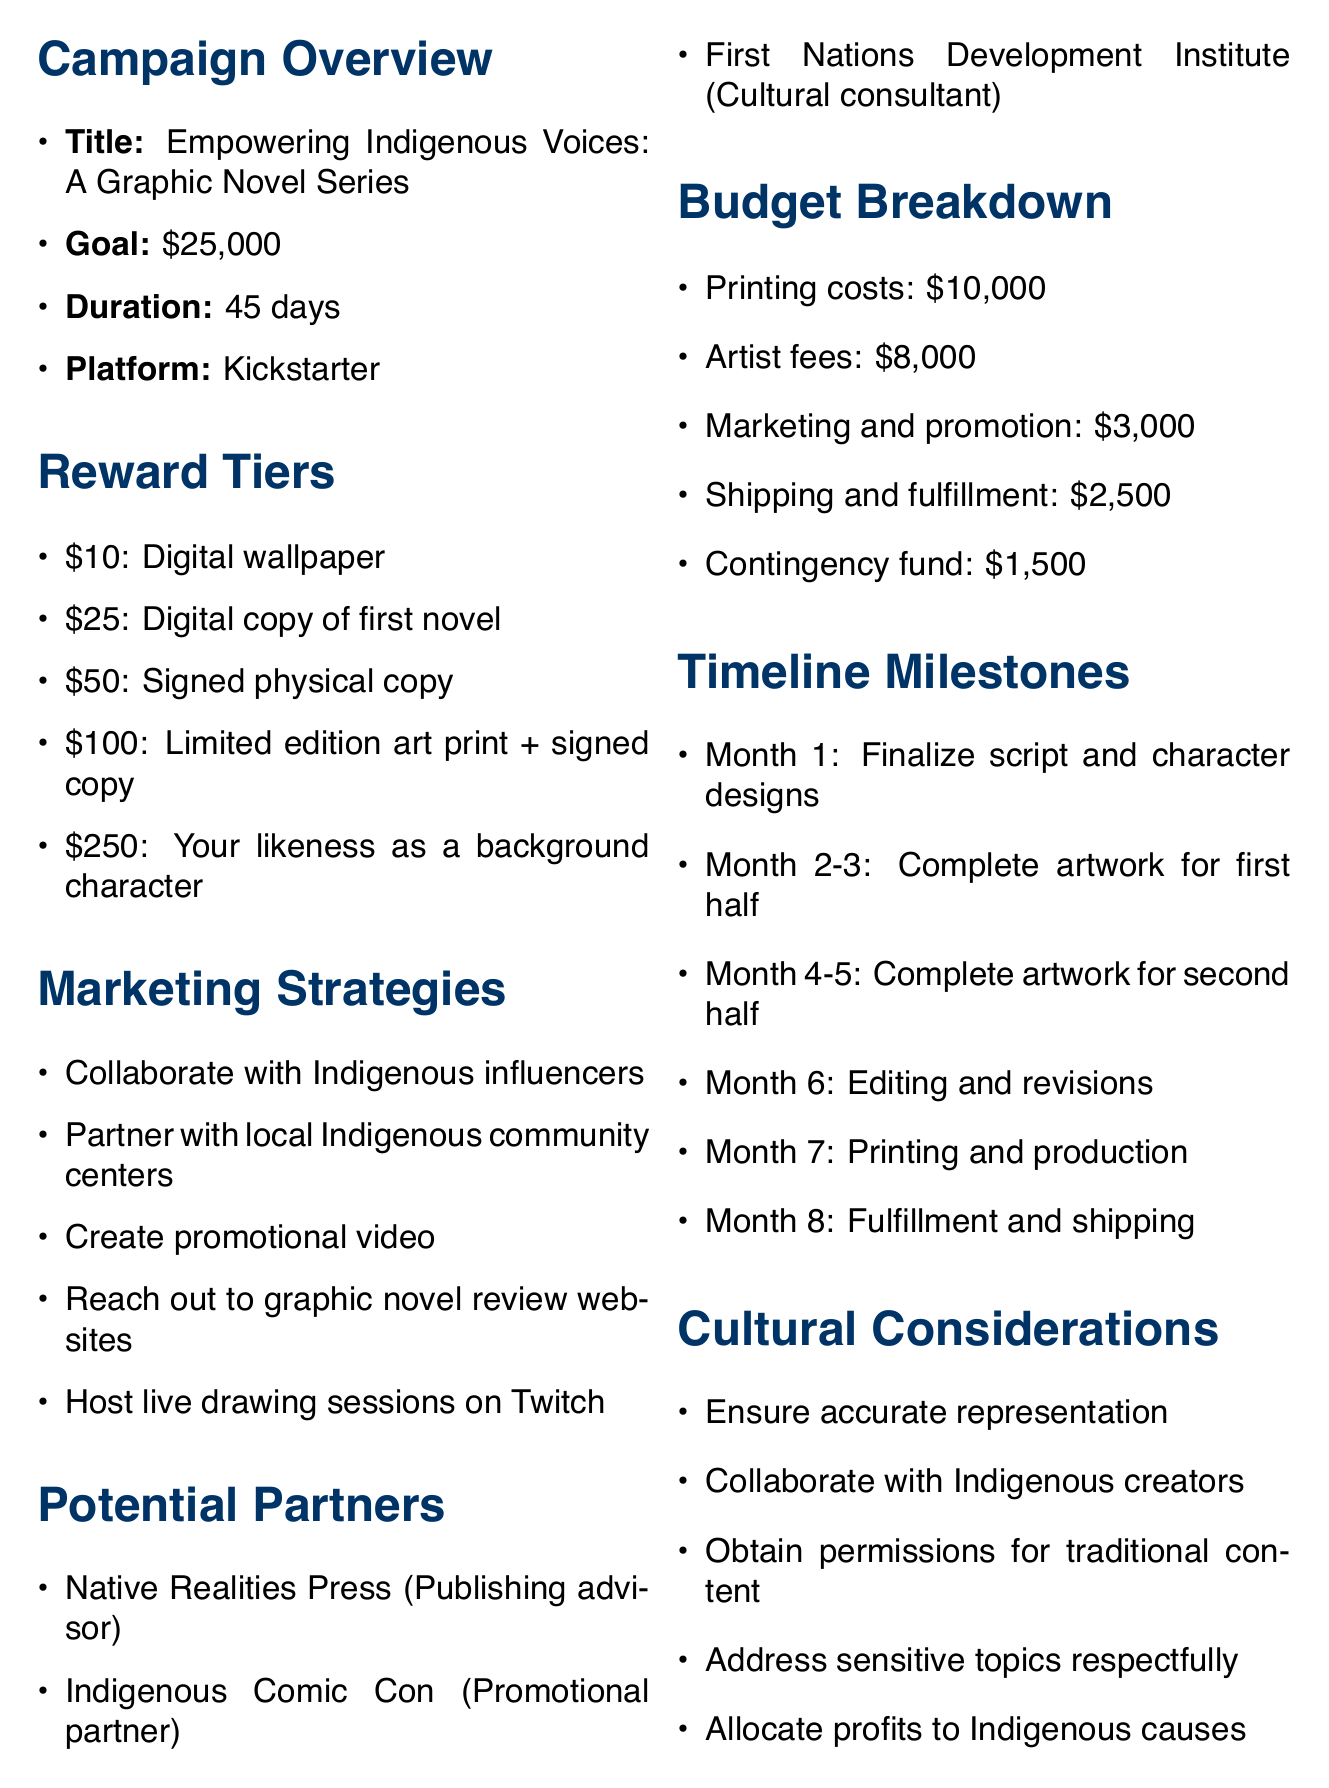What is the campaign title? The campaign title is listed in the campaign overview section of the document.
Answer: Empowering Indigenous Voices: A Graphic Novel Series What is the funding goal? The funding goal is specified in the campaign overview section.
Answer: $25,000 How long is the campaign duration? The duration of the campaign is mentioned in the overview section.
Answer: 45 days What is the highest reward tier amount? The highest reward tier amount can be found in the reward tiers section.
Answer: $250 What are the first two timeline milestones? The first two milestones are outlined in the timeline section and require reference to specific months.
Answer: Month 1: Finalize script and character designs; Month 2-3: Complete artwork for first half of the graphic novel Which organization is listed as a cultural consultant? The potential partners section lists all organizations involved, including their roles.
Answer: First Nations Development Institute What is allocated for contingency funds? The budget breakdown itemizes all funding requirements, including contingency funds.
Answer: $1,500 Name one marketing strategy. The marketing strategies section provides various tactics for promoting the campaign.
Answer: Collaborate with Indigenous influencers on social media What is the purpose of the project? The purpose of the project can be inferred from the campaign title and overview section.
Answer: A graphic novel series that empowers Indigenous voices 